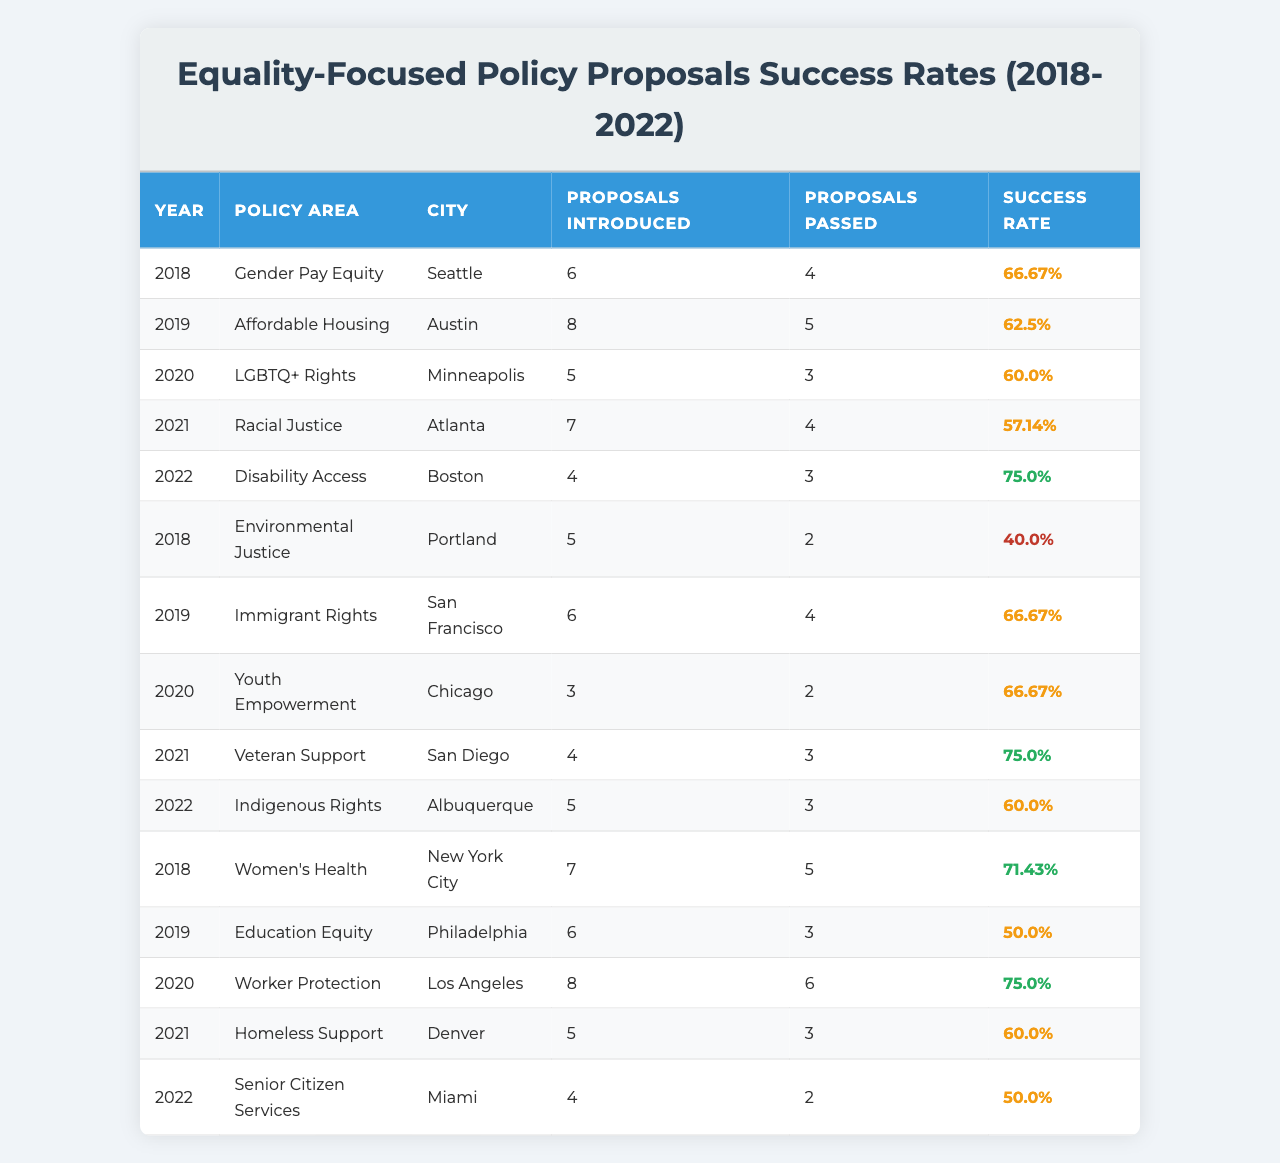What is the highest success rate of a policy proposal in the table? The highest success rate can be determined by comparing the success rates listed in the last column of the table. The values are 66.67, 62.5, 60.0, 57.14, 75.0, 40.0, 66.67, 66.67, 75.0, 60.0, 71.43, 50.0, 75.0, 60.0, and 50.0. The maximum value among these is 75.0%.
Answer: 75.0% Which city had the lowest success rate for equality-focused policy proposals? To find the lowest success rate, I must evaluate all the success rates provided in the last column. The values are: 66.67, 62.5, 60.0, 57.14, 75.0, 40.0, 66.67, 66.67, 75.0, 60.0, 71.43, 50.0, 75.0, 60.0, and 50.0. The lowest is 40.0%, which corresponds to Portland for Environmental Justice.
Answer: Portland How many proposals were introduced for LGBTQ+ Rights in 2020? The table lists specific values for each Policy Area and Year. Looking under the year 2020 and the policy area "LGBTQ+ Rights", it shows 5 proposals were introduced.
Answer: 5 What is the average success rate of proposals from the year 2019? The success rates from 2019 are 62.5 (Affordable Housing), 66.67 (Immigrant Rights), and 50.0 (Education Equity). To find the average, I need to sum these rates (62.5 + 66.67 + 50.0 = 179.17) and divide by 3 (the number of proposals). Thus, the average success rate is 179.17 / 3 = 59.72%.
Answer: 59.72% Did any proposals in 2022 achieve a success rate above 70%? In 2022, the proposals were for "Disability Access" (75.0%) and "Indigenous Rights" (60.0%). Since 75.0% is greater than 70%, there is at least one proposal that meets the criteria.
Answer: Yes Which policy area had the highest number of proposals introduced in the year 2020? In 2020, I can check the proposals introduced for each policy. The counts are: LGBTQ+ Rights (5), Worker Protection (8). The highest is 8 proposals for Worker Protection.
Answer: Worker Protection How many total proposals were passed and what was the total success rate across all years? To find the total proposals passed, I sum up the values from the "Proposals Passed" column (4 + 5 + 3 + 4 + 3 + 2 + 4 + 2 + 3 + 3 + 5 + 3 + 6 + 3 + 2 = 58). The total proposals introduced is the sum from the "Proposals Introduced" column (6 + 8 + 5 + 7 + 4 + 5 + 6 + 3 + 4 + 5 + 7 + 6 + 8 + 5 + 4 = 80). The success rate is (58 / 80) * 100 = 72.5%.
Answer: 72.5% What year had the most proposals passed? I need to compare the number of proposals passed in each year: 2018 (9), 2019 (12), 2020 (11), 2021 (10), 2022 (5). The year with the most proposals passed is 2019 with 12 proposals approved.
Answer: 2019 